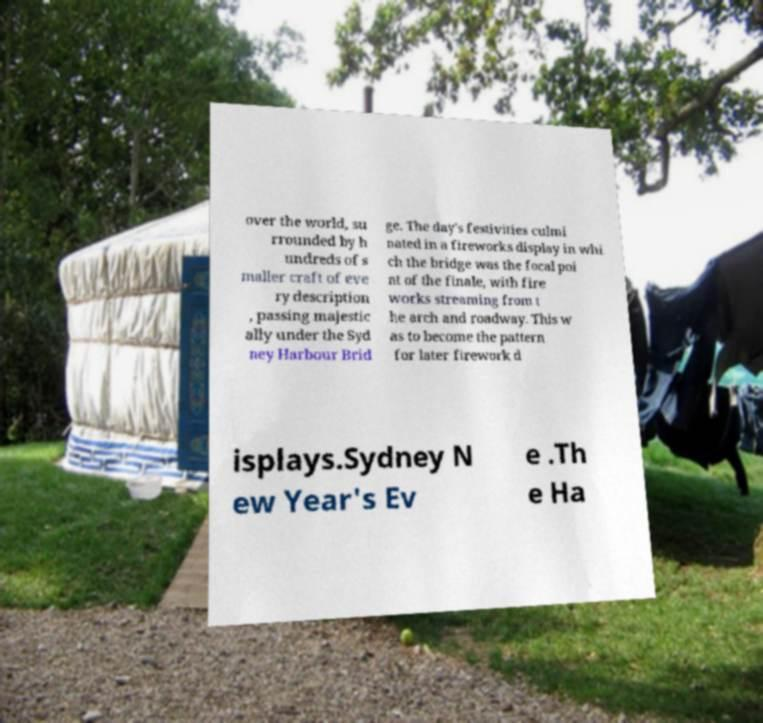Can you read and provide the text displayed in the image?This photo seems to have some interesting text. Can you extract and type it out for me? over the world, su rrounded by h undreds of s maller craft of eve ry description , passing majestic ally under the Syd ney Harbour Brid ge. The day's festivities culmi nated in a fireworks display in whi ch the bridge was the focal poi nt of the finale, with fire works streaming from t he arch and roadway. This w as to become the pattern for later firework d isplays.Sydney N ew Year's Ev e .Th e Ha 